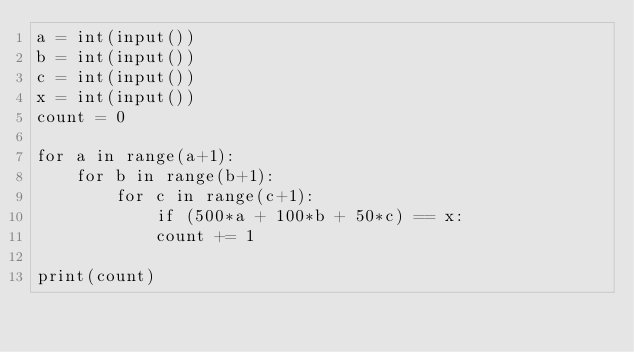Convert code to text. <code><loc_0><loc_0><loc_500><loc_500><_Python_>a = int(input())
b = int(input())
c = int(input())
x = int(input())
count = 0

for a in range(a+1):
    for b in range(b+1):
        for c in range(c+1):
            if (500*a + 100*b + 50*c) == x:
            count += 1

print(count)

</code> 